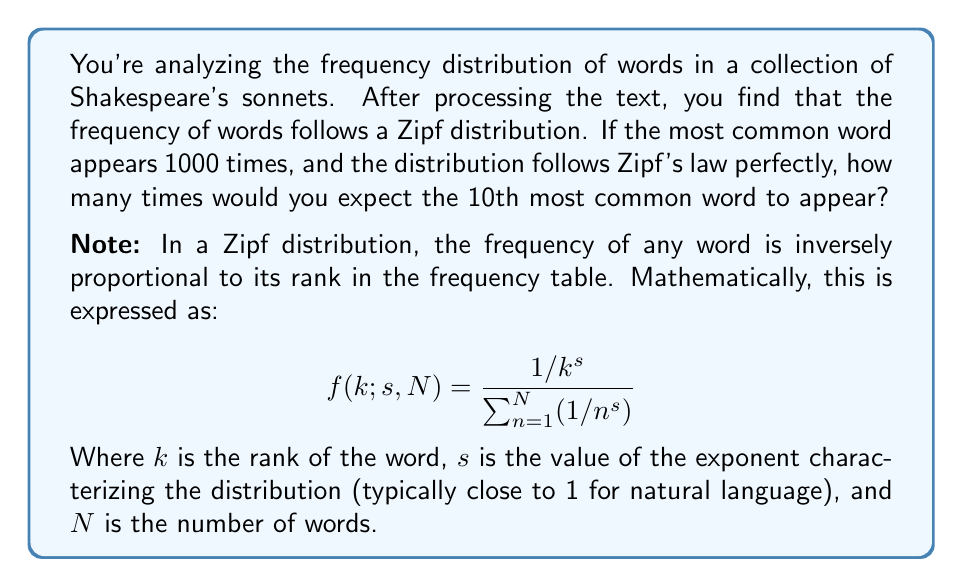Teach me how to tackle this problem. Let's approach this step-by-step:

1) In a perfect Zipf distribution with $s=1$, the frequency of a word is inversely proportional to its rank. This means:

   $$ f_k \propto \frac{1}{k} $$

   Where $f_k$ is the frequency of the word with rank $k$.

2) We're told that the most common word (rank 1) appears 1000 times. So:

   $$ f_1 = 1000 $$

3) For the 10th most common word, we need to find $f_{10}$. The proportion between $f_1$ and $f_{10}$ is:

   $$ \frac{f_1}{f_{10}} = \frac{1/1}{1/10} = 10 $$

4) This means that $f_1$ is 10 times larger than $f_{10}$. We can set up the equation:

   $$ \frac{1000}{f_{10}} = 10 $$

5) Solving for $f_{10}$:

   $$ f_{10} = \frac{1000}{10} = 100 $$

Therefore, we would expect the 10th most common word to appear 100 times in the corpus.
Answer: 100 times 